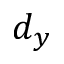<formula> <loc_0><loc_0><loc_500><loc_500>d _ { y }</formula> 